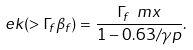Convert formula to latex. <formula><loc_0><loc_0><loc_500><loc_500>\ e k ( > \Gamma _ { f } \beta _ { f } ) = \frac { \Gamma _ { f } \ m x } { 1 - 0 . 6 3 / \gamma p } .</formula> 